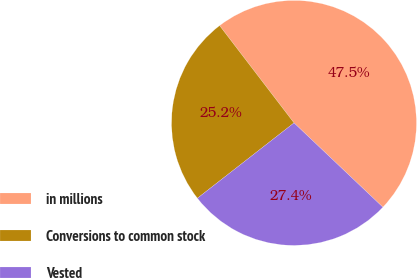Convert chart. <chart><loc_0><loc_0><loc_500><loc_500><pie_chart><fcel>in millions<fcel>Conversions to common stock<fcel>Vested<nl><fcel>47.47%<fcel>25.15%<fcel>27.38%<nl></chart> 